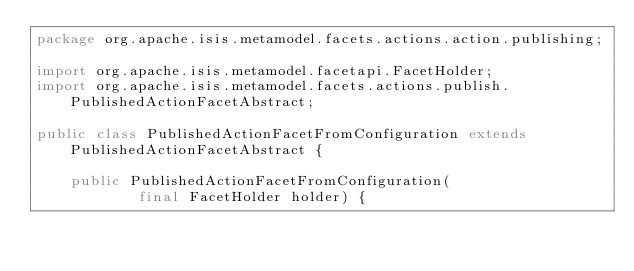Convert code to text. <code><loc_0><loc_0><loc_500><loc_500><_Java_>package org.apache.isis.metamodel.facets.actions.action.publishing;

import org.apache.isis.metamodel.facetapi.FacetHolder;
import org.apache.isis.metamodel.facets.actions.publish.PublishedActionFacetAbstract;

public class PublishedActionFacetFromConfiguration extends PublishedActionFacetAbstract {

    public PublishedActionFacetFromConfiguration(
            final FacetHolder holder) {</code> 